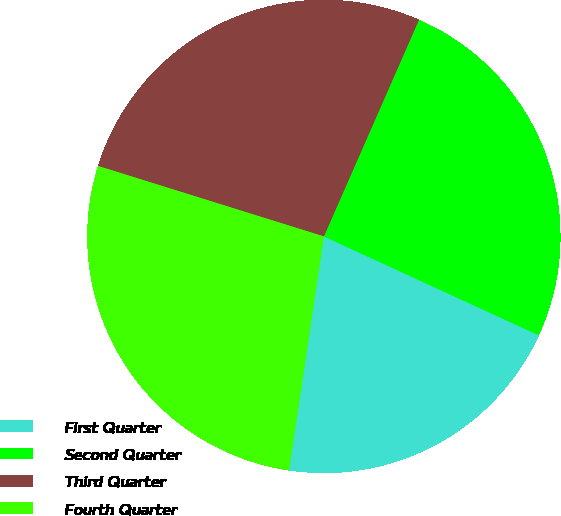<chart> <loc_0><loc_0><loc_500><loc_500><pie_chart><fcel>First Quarter<fcel>Second Quarter<fcel>Third Quarter<fcel>Fourth Quarter<nl><fcel>20.49%<fcel>25.28%<fcel>26.77%<fcel>27.46%<nl></chart> 